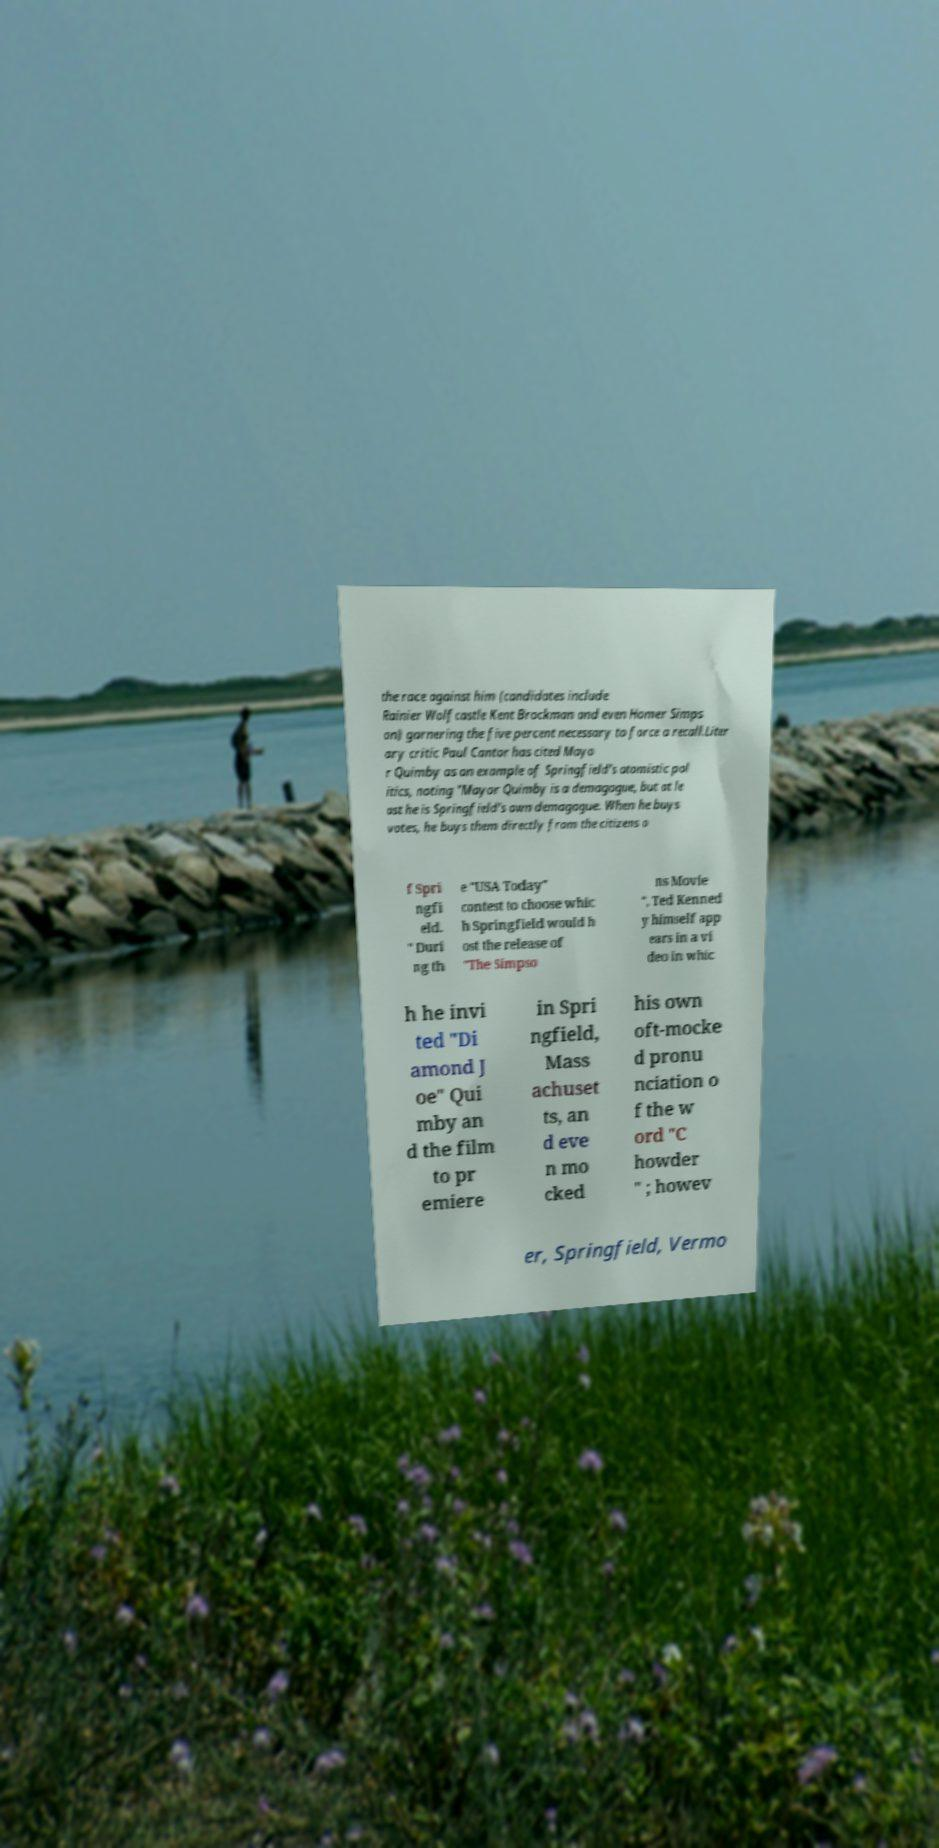For documentation purposes, I need the text within this image transcribed. Could you provide that? the race against him (candidates include Rainier Wolfcastle Kent Brockman and even Homer Simps on) garnering the five percent necessary to force a recall.Liter ary critic Paul Cantor has cited Mayo r Quimby as an example of Springfield's atomistic pol itics, noting "Mayor Quimby is a demagogue, but at le ast he is Springfield's own demagogue. When he buys votes, he buys them directly from the citizens o f Spri ngfi eld. " Duri ng th e "USA Today" contest to choose whic h Springfield would h ost the release of "The Simpso ns Movie ", Ted Kenned y himself app ears in a vi deo in whic h he invi ted "Di amond J oe" Qui mby an d the film to pr emiere in Spri ngfield, Mass achuset ts, an d eve n mo cked his own oft-mocke d pronu nciation o f the w ord "C howder " ; howev er, Springfield, Vermo 